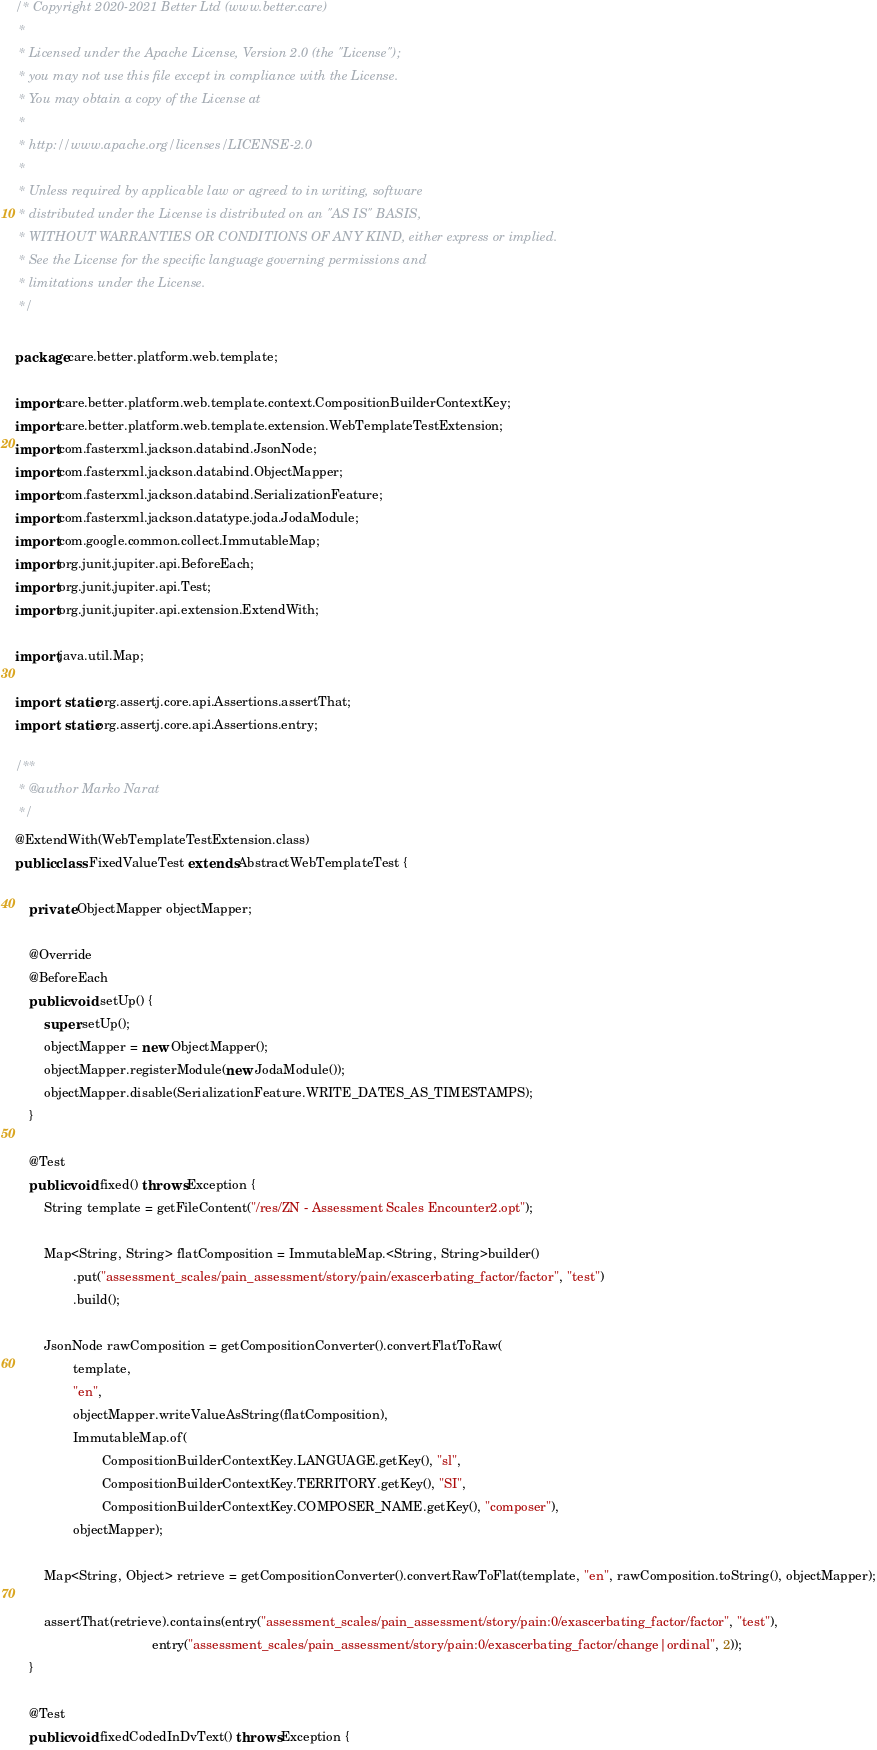<code> <loc_0><loc_0><loc_500><loc_500><_Java_>/* Copyright 2020-2021 Better Ltd (www.better.care)
 *
 * Licensed under the Apache License, Version 2.0 (the "License");
 * you may not use this file except in compliance with the License.
 * You may obtain a copy of the License at
 *
 * http://www.apache.org/licenses/LICENSE-2.0
 *
 * Unless required by applicable law or agreed to in writing, software
 * distributed under the License is distributed on an "AS IS" BASIS,
 * WITHOUT WARRANTIES OR CONDITIONS OF ANY KIND, either express or implied.
 * See the License for the specific language governing permissions and
 * limitations under the License.
 */

package care.better.platform.web.template;

import care.better.platform.web.template.context.CompositionBuilderContextKey;
import care.better.platform.web.template.extension.WebTemplateTestExtension;
import com.fasterxml.jackson.databind.JsonNode;
import com.fasterxml.jackson.databind.ObjectMapper;
import com.fasterxml.jackson.databind.SerializationFeature;
import com.fasterxml.jackson.datatype.joda.JodaModule;
import com.google.common.collect.ImmutableMap;
import org.junit.jupiter.api.BeforeEach;
import org.junit.jupiter.api.Test;
import org.junit.jupiter.api.extension.ExtendWith;

import java.util.Map;

import static org.assertj.core.api.Assertions.assertThat;
import static org.assertj.core.api.Assertions.entry;

/**
 * @author Marko Narat
 */
@ExtendWith(WebTemplateTestExtension.class)
public class FixedValueTest extends AbstractWebTemplateTest {

    private ObjectMapper objectMapper;

    @Override
    @BeforeEach
    public void setUp() {
        super.setUp();
        objectMapper = new ObjectMapper();
        objectMapper.registerModule(new JodaModule());
        objectMapper.disable(SerializationFeature.WRITE_DATES_AS_TIMESTAMPS);
    }

    @Test
    public void fixed() throws Exception {
        String template = getFileContent("/res/ZN - Assessment Scales Encounter2.opt");

        Map<String, String> flatComposition = ImmutableMap.<String, String>builder()
                .put("assessment_scales/pain_assessment/story/pain/exascerbating_factor/factor", "test")
                .build();

        JsonNode rawComposition = getCompositionConverter().convertFlatToRaw(
                template,
                "en",
                objectMapper.writeValueAsString(flatComposition),
                ImmutableMap.of(
                        CompositionBuilderContextKey.LANGUAGE.getKey(), "sl",
                        CompositionBuilderContextKey.TERRITORY.getKey(), "SI",
                        CompositionBuilderContextKey.COMPOSER_NAME.getKey(), "composer"),
                objectMapper);

        Map<String, Object> retrieve = getCompositionConverter().convertRawToFlat(template, "en", rawComposition.toString(), objectMapper);

        assertThat(retrieve).contains(entry("assessment_scales/pain_assessment/story/pain:0/exascerbating_factor/factor", "test"),
                                      entry("assessment_scales/pain_assessment/story/pain:0/exascerbating_factor/change|ordinal", 2));
    }

    @Test
    public void fixedCodedInDvText() throws Exception {</code> 